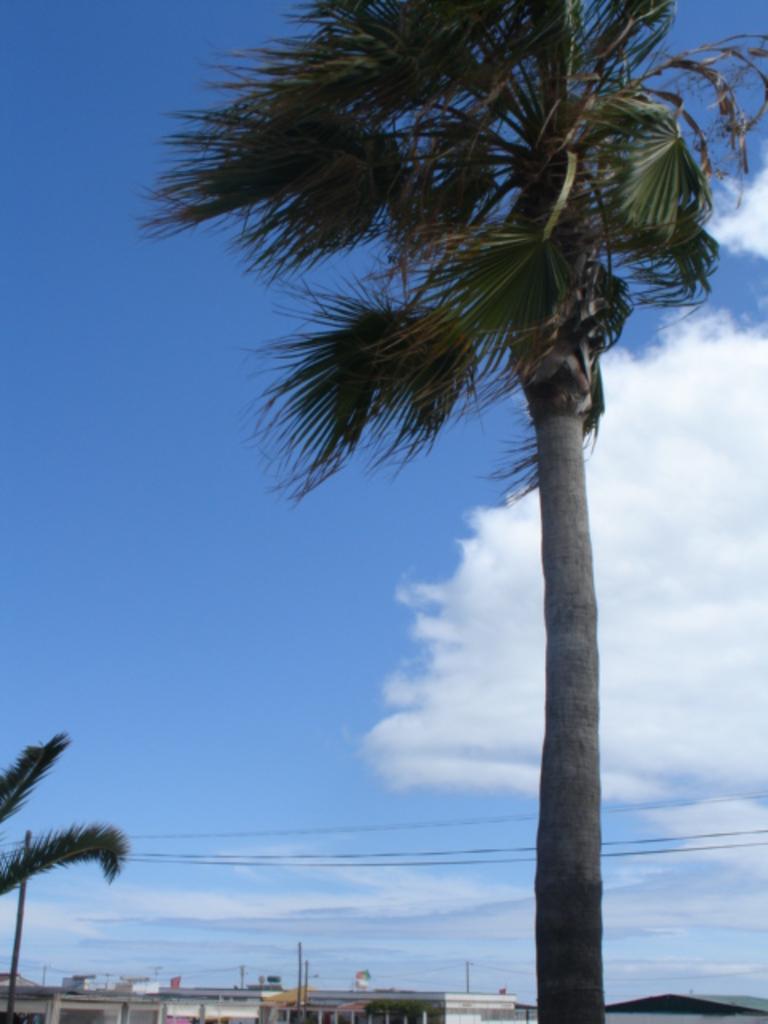Could you give a brief overview of what you see in this image? In the foreground we can see trees. In the background, we can see some buildings, poles with cables and the cloudy sky. 